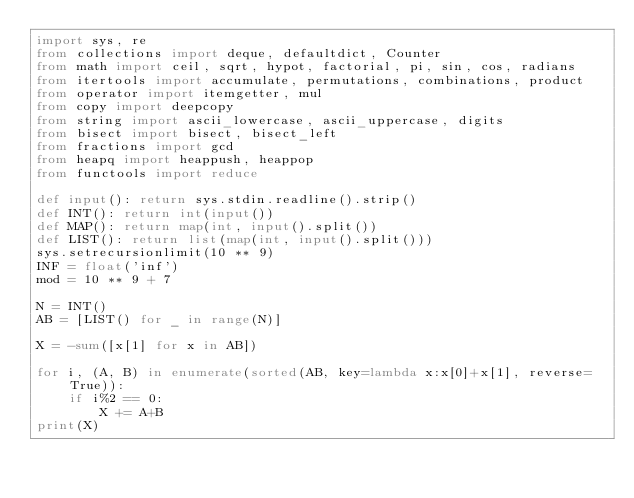Convert code to text. <code><loc_0><loc_0><loc_500><loc_500><_Python_>import sys, re
from collections import deque, defaultdict, Counter
from math import ceil, sqrt, hypot, factorial, pi, sin, cos, radians
from itertools import accumulate, permutations, combinations, product
from operator import itemgetter, mul
from copy import deepcopy
from string import ascii_lowercase, ascii_uppercase, digits
from bisect import bisect, bisect_left
from fractions import gcd
from heapq import heappush, heappop
from functools import reduce

def input(): return sys.stdin.readline().strip()
def INT(): return int(input())
def MAP(): return map(int, input().split())
def LIST(): return list(map(int, input().split()))
sys.setrecursionlimit(10 ** 9)
INF = float('inf')
mod = 10 ** 9 + 7

N = INT()
AB = [LIST() for _ in range(N)]

X = -sum([x[1] for x in AB])

for i, (A, B) in enumerate(sorted(AB, key=lambda x:x[0]+x[1], reverse=True)):
	if i%2 == 0:
		X += A+B
print(X)
</code> 